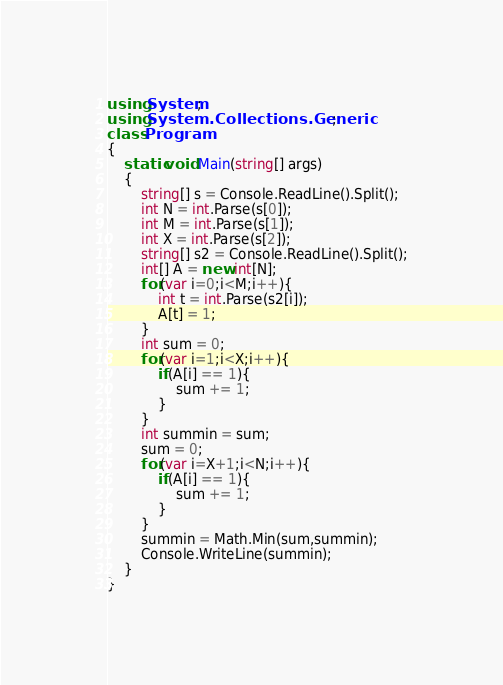Convert code to text. <code><loc_0><loc_0><loc_500><loc_500><_C#_>using System;
using System.Collections.Generic;
class Program
{
	static void Main(string[] args)
	{
		string[] s = Console.ReadLine().Split();
		int N = int.Parse(s[0]);
		int M = int.Parse(s[1]);
		int X = int.Parse(s[2]);
		string[] s2 = Console.ReadLine().Split();
		int[] A = new int[N];
		for(var i=0;i<M;i++){
			int t = int.Parse(s2[i]);
			A[t] = 1;
		}
		int sum = 0;
		for(var i=1;i<X;i++){
			if(A[i] == 1){
				sum += 1;
			}
		}
		int summin = sum;
		sum = 0;
		for(var i=X+1;i<N;i++){
			if(A[i] == 1){
				sum += 1;
			}
		}
		summin = Math.Min(sum,summin);
		Console.WriteLine(summin);
	}
}</code> 